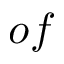Convert formula to latex. <formula><loc_0><loc_0><loc_500><loc_500>o f</formula> 